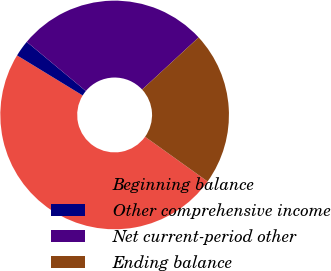<chart> <loc_0><loc_0><loc_500><loc_500><pie_chart><fcel>Beginning balance<fcel>Other comprehensive income<fcel>Net current-period other<fcel>Ending balance<nl><fcel>48.84%<fcel>2.32%<fcel>27.09%<fcel>21.75%<nl></chart> 